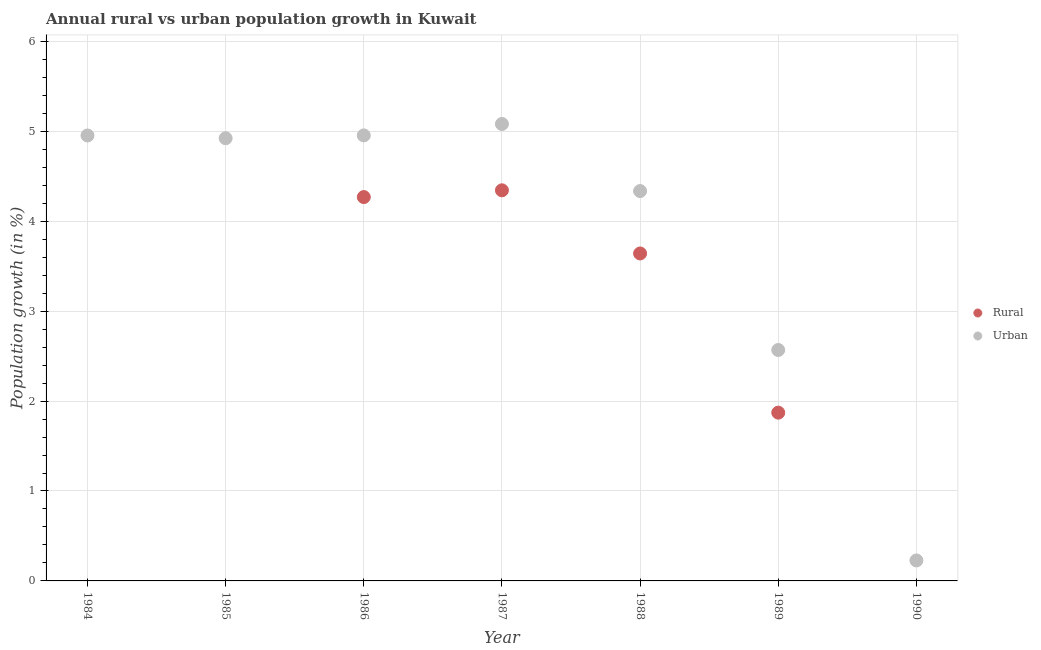How many different coloured dotlines are there?
Offer a very short reply. 2. Across all years, what is the maximum rural population growth?
Your answer should be very brief. 4.34. Across all years, what is the minimum urban population growth?
Offer a terse response. 0.23. In which year was the urban population growth maximum?
Provide a succinct answer. 1987. What is the total rural population growth in the graph?
Your answer should be compact. 14.13. What is the difference between the rural population growth in 1988 and that in 1989?
Ensure brevity in your answer.  1.77. What is the difference between the urban population growth in 1990 and the rural population growth in 1988?
Provide a succinct answer. -3.41. What is the average urban population growth per year?
Ensure brevity in your answer.  3.86. In the year 1987, what is the difference between the rural population growth and urban population growth?
Keep it short and to the point. -0.74. What is the ratio of the urban population growth in 1984 to that in 1985?
Make the answer very short. 1.01. Is the difference between the rural population growth in 1987 and 1988 greater than the difference between the urban population growth in 1987 and 1988?
Your answer should be very brief. No. What is the difference between the highest and the second highest urban population growth?
Ensure brevity in your answer.  0.13. What is the difference between the highest and the lowest urban population growth?
Make the answer very short. 4.85. In how many years, is the rural population growth greater than the average rural population growth taken over all years?
Give a very brief answer. 3. Is the rural population growth strictly greater than the urban population growth over the years?
Keep it short and to the point. No. Is the rural population growth strictly less than the urban population growth over the years?
Provide a short and direct response. Yes. What is the difference between two consecutive major ticks on the Y-axis?
Provide a short and direct response. 1. Are the values on the major ticks of Y-axis written in scientific E-notation?
Make the answer very short. No. Where does the legend appear in the graph?
Ensure brevity in your answer.  Center right. How many legend labels are there?
Provide a succinct answer. 2. How are the legend labels stacked?
Offer a very short reply. Vertical. What is the title of the graph?
Provide a succinct answer. Annual rural vs urban population growth in Kuwait. Does "Register a business" appear as one of the legend labels in the graph?
Offer a very short reply. No. What is the label or title of the Y-axis?
Give a very brief answer. Population growth (in %). What is the Population growth (in %) of Urban  in 1984?
Offer a very short reply. 4.95. What is the Population growth (in %) in Rural in 1985?
Ensure brevity in your answer.  0. What is the Population growth (in %) of Urban  in 1985?
Offer a very short reply. 4.92. What is the Population growth (in %) in Rural in 1986?
Your answer should be very brief. 4.27. What is the Population growth (in %) in Urban  in 1986?
Give a very brief answer. 4.95. What is the Population growth (in %) of Rural in 1987?
Offer a very short reply. 4.34. What is the Population growth (in %) in Urban  in 1987?
Keep it short and to the point. 5.08. What is the Population growth (in %) in Rural in 1988?
Offer a very short reply. 3.64. What is the Population growth (in %) of Urban  in 1988?
Offer a terse response. 4.34. What is the Population growth (in %) in Rural in 1989?
Your answer should be very brief. 1.87. What is the Population growth (in %) of Urban  in 1989?
Your answer should be compact. 2.57. What is the Population growth (in %) in Urban  in 1990?
Your answer should be compact. 0.23. Across all years, what is the maximum Population growth (in %) in Rural?
Give a very brief answer. 4.34. Across all years, what is the maximum Population growth (in %) of Urban ?
Ensure brevity in your answer.  5.08. Across all years, what is the minimum Population growth (in %) in Rural?
Ensure brevity in your answer.  0. Across all years, what is the minimum Population growth (in %) of Urban ?
Offer a very short reply. 0.23. What is the total Population growth (in %) of Rural in the graph?
Your answer should be compact. 14.13. What is the total Population growth (in %) in Urban  in the graph?
Offer a very short reply. 27.04. What is the difference between the Population growth (in %) of Urban  in 1984 and that in 1985?
Keep it short and to the point. 0.03. What is the difference between the Population growth (in %) of Urban  in 1984 and that in 1986?
Offer a very short reply. -0. What is the difference between the Population growth (in %) of Urban  in 1984 and that in 1987?
Offer a terse response. -0.13. What is the difference between the Population growth (in %) in Urban  in 1984 and that in 1988?
Offer a very short reply. 0.62. What is the difference between the Population growth (in %) of Urban  in 1984 and that in 1989?
Your answer should be very brief. 2.39. What is the difference between the Population growth (in %) of Urban  in 1984 and that in 1990?
Your answer should be compact. 4.73. What is the difference between the Population growth (in %) of Urban  in 1985 and that in 1986?
Your response must be concise. -0.03. What is the difference between the Population growth (in %) of Urban  in 1985 and that in 1987?
Offer a very short reply. -0.16. What is the difference between the Population growth (in %) of Urban  in 1985 and that in 1988?
Provide a short and direct response. 0.59. What is the difference between the Population growth (in %) of Urban  in 1985 and that in 1989?
Your answer should be very brief. 2.36. What is the difference between the Population growth (in %) in Urban  in 1985 and that in 1990?
Your response must be concise. 4.7. What is the difference between the Population growth (in %) in Rural in 1986 and that in 1987?
Make the answer very short. -0.08. What is the difference between the Population growth (in %) of Urban  in 1986 and that in 1987?
Your response must be concise. -0.13. What is the difference between the Population growth (in %) in Rural in 1986 and that in 1988?
Make the answer very short. 0.63. What is the difference between the Population growth (in %) in Urban  in 1986 and that in 1988?
Your answer should be compact. 0.62. What is the difference between the Population growth (in %) of Rural in 1986 and that in 1989?
Give a very brief answer. 2.4. What is the difference between the Population growth (in %) of Urban  in 1986 and that in 1989?
Your answer should be very brief. 2.39. What is the difference between the Population growth (in %) of Urban  in 1986 and that in 1990?
Make the answer very short. 4.73. What is the difference between the Population growth (in %) in Rural in 1987 and that in 1988?
Offer a very short reply. 0.7. What is the difference between the Population growth (in %) in Urban  in 1987 and that in 1988?
Offer a very short reply. 0.75. What is the difference between the Population growth (in %) of Rural in 1987 and that in 1989?
Keep it short and to the point. 2.47. What is the difference between the Population growth (in %) in Urban  in 1987 and that in 1989?
Your answer should be very brief. 2.51. What is the difference between the Population growth (in %) in Urban  in 1987 and that in 1990?
Make the answer very short. 4.85. What is the difference between the Population growth (in %) in Rural in 1988 and that in 1989?
Your response must be concise. 1.77. What is the difference between the Population growth (in %) in Urban  in 1988 and that in 1989?
Offer a terse response. 1.77. What is the difference between the Population growth (in %) of Urban  in 1988 and that in 1990?
Offer a very short reply. 4.11. What is the difference between the Population growth (in %) in Urban  in 1989 and that in 1990?
Your answer should be compact. 2.34. What is the difference between the Population growth (in %) of Rural in 1986 and the Population growth (in %) of Urban  in 1987?
Your answer should be very brief. -0.81. What is the difference between the Population growth (in %) in Rural in 1986 and the Population growth (in %) in Urban  in 1988?
Your response must be concise. -0.07. What is the difference between the Population growth (in %) of Rural in 1986 and the Population growth (in %) of Urban  in 1989?
Ensure brevity in your answer.  1.7. What is the difference between the Population growth (in %) in Rural in 1986 and the Population growth (in %) in Urban  in 1990?
Your answer should be compact. 4.04. What is the difference between the Population growth (in %) of Rural in 1987 and the Population growth (in %) of Urban  in 1988?
Provide a short and direct response. 0.01. What is the difference between the Population growth (in %) of Rural in 1987 and the Population growth (in %) of Urban  in 1989?
Give a very brief answer. 1.78. What is the difference between the Population growth (in %) of Rural in 1987 and the Population growth (in %) of Urban  in 1990?
Give a very brief answer. 4.12. What is the difference between the Population growth (in %) of Rural in 1988 and the Population growth (in %) of Urban  in 1989?
Make the answer very short. 1.07. What is the difference between the Population growth (in %) of Rural in 1988 and the Population growth (in %) of Urban  in 1990?
Ensure brevity in your answer.  3.41. What is the difference between the Population growth (in %) of Rural in 1989 and the Population growth (in %) of Urban  in 1990?
Offer a very short reply. 1.64. What is the average Population growth (in %) of Rural per year?
Ensure brevity in your answer.  2.02. What is the average Population growth (in %) of Urban  per year?
Your answer should be compact. 3.86. In the year 1986, what is the difference between the Population growth (in %) of Rural and Population growth (in %) of Urban ?
Provide a succinct answer. -0.69. In the year 1987, what is the difference between the Population growth (in %) in Rural and Population growth (in %) in Urban ?
Keep it short and to the point. -0.74. In the year 1988, what is the difference between the Population growth (in %) of Rural and Population growth (in %) of Urban ?
Your answer should be very brief. -0.69. In the year 1989, what is the difference between the Population growth (in %) of Rural and Population growth (in %) of Urban ?
Provide a short and direct response. -0.7. What is the ratio of the Population growth (in %) of Urban  in 1984 to that in 1985?
Provide a short and direct response. 1.01. What is the ratio of the Population growth (in %) in Urban  in 1984 to that in 1987?
Provide a short and direct response. 0.97. What is the ratio of the Population growth (in %) in Urban  in 1984 to that in 1988?
Provide a short and direct response. 1.14. What is the ratio of the Population growth (in %) of Urban  in 1984 to that in 1989?
Provide a short and direct response. 1.93. What is the ratio of the Population growth (in %) of Urban  in 1984 to that in 1990?
Ensure brevity in your answer.  21.75. What is the ratio of the Population growth (in %) in Urban  in 1985 to that in 1987?
Make the answer very short. 0.97. What is the ratio of the Population growth (in %) of Urban  in 1985 to that in 1988?
Ensure brevity in your answer.  1.14. What is the ratio of the Population growth (in %) of Urban  in 1985 to that in 1989?
Make the answer very short. 1.92. What is the ratio of the Population growth (in %) of Urban  in 1985 to that in 1990?
Your response must be concise. 21.62. What is the ratio of the Population growth (in %) of Rural in 1986 to that in 1987?
Provide a short and direct response. 0.98. What is the ratio of the Population growth (in %) of Rural in 1986 to that in 1988?
Your answer should be very brief. 1.17. What is the ratio of the Population growth (in %) of Urban  in 1986 to that in 1988?
Provide a succinct answer. 1.14. What is the ratio of the Population growth (in %) of Rural in 1986 to that in 1989?
Your response must be concise. 2.28. What is the ratio of the Population growth (in %) in Urban  in 1986 to that in 1989?
Your response must be concise. 1.93. What is the ratio of the Population growth (in %) in Urban  in 1986 to that in 1990?
Offer a terse response. 21.76. What is the ratio of the Population growth (in %) in Rural in 1987 to that in 1988?
Provide a short and direct response. 1.19. What is the ratio of the Population growth (in %) of Urban  in 1987 to that in 1988?
Make the answer very short. 1.17. What is the ratio of the Population growth (in %) of Rural in 1987 to that in 1989?
Keep it short and to the point. 2.32. What is the ratio of the Population growth (in %) in Urban  in 1987 to that in 1989?
Offer a very short reply. 1.98. What is the ratio of the Population growth (in %) of Urban  in 1987 to that in 1990?
Your answer should be very brief. 22.32. What is the ratio of the Population growth (in %) of Rural in 1988 to that in 1989?
Your answer should be compact. 1.95. What is the ratio of the Population growth (in %) in Urban  in 1988 to that in 1989?
Ensure brevity in your answer.  1.69. What is the ratio of the Population growth (in %) of Urban  in 1988 to that in 1990?
Give a very brief answer. 19.04. What is the ratio of the Population growth (in %) of Urban  in 1989 to that in 1990?
Keep it short and to the point. 11.28. What is the difference between the highest and the second highest Population growth (in %) in Rural?
Your response must be concise. 0.08. What is the difference between the highest and the second highest Population growth (in %) in Urban ?
Offer a very short reply. 0.13. What is the difference between the highest and the lowest Population growth (in %) in Rural?
Your answer should be very brief. 4.34. What is the difference between the highest and the lowest Population growth (in %) in Urban ?
Keep it short and to the point. 4.85. 